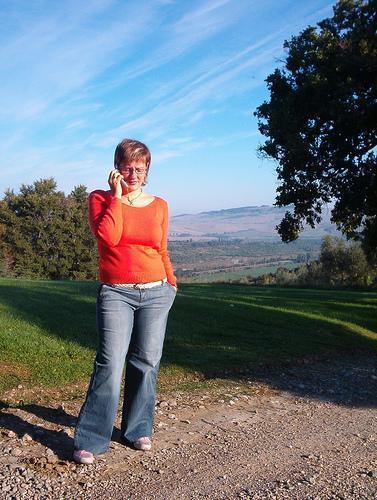How many dogs are playing in the field behind the woman?
Give a very brief answer. 0. 